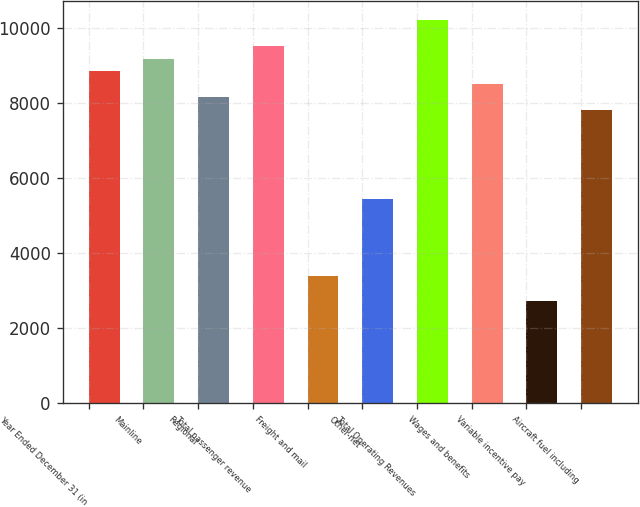Convert chart. <chart><loc_0><loc_0><loc_500><loc_500><bar_chart><fcel>Year Ended December 31 (in<fcel>Mainline<fcel>Regional<fcel>Total passenger revenue<fcel>Freight and mail<fcel>Other-net<fcel>Total Operating Revenues<fcel>Wages and benefits<fcel>Variable incentive pay<fcel>Aircraft fuel including<nl><fcel>8834<fcel>9173.64<fcel>8154.72<fcel>9513.28<fcel>3399.76<fcel>5437.6<fcel>10192.6<fcel>8494.36<fcel>2720.48<fcel>7815.08<nl></chart> 